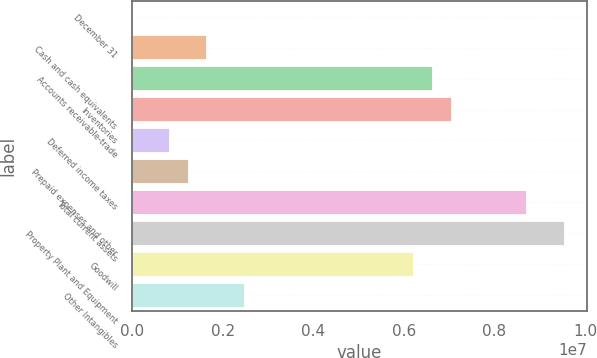Convert chart to OTSL. <chart><loc_0><loc_0><loc_500><loc_500><bar_chart><fcel>December 31<fcel>Cash and cash equivalents<fcel>Accounts receivable-trade<fcel>Inventories<fcel>Deferred income taxes<fcel>Prepaid expenses and other<fcel>Total current assets<fcel>Property Plant and Equipment<fcel>Goodwill<fcel>Other Intangibles<nl><fcel>2006<fcel>1.66423e+06<fcel>6.6509e+06<fcel>7.06646e+06<fcel>833118<fcel>1.24867e+06<fcel>8.72868e+06<fcel>9.55979e+06<fcel>6.23534e+06<fcel>2.49534e+06<nl></chart> 